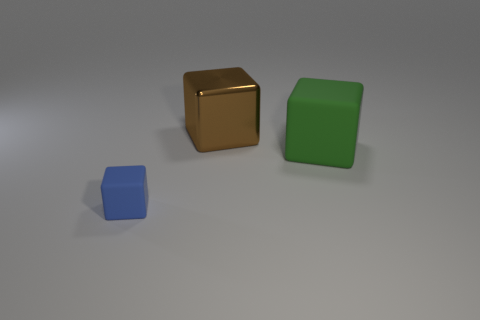How many other objects are there of the same material as the blue object?
Your answer should be compact. 1. Does the green cube have the same material as the block to the left of the brown shiny block?
Keep it short and to the point. Yes. What number of things are either blue objects that are on the left side of the brown block or objects that are in front of the large green object?
Ensure brevity in your answer.  1. What number of other things are there of the same color as the small matte object?
Your response must be concise. 0. Are there more brown metallic cubes behind the big brown metallic block than small blocks that are right of the large green thing?
Your response must be concise. No. Is there any other thing that has the same size as the brown metal cube?
Provide a succinct answer. Yes. What number of cubes are either big shiny objects or big green things?
Your answer should be compact. 2. How many objects are matte cubes that are to the left of the large metal object or green objects?
Provide a succinct answer. 2. What shape is the rubber thing that is on the right side of the rubber thing in front of the thing that is right of the large brown block?
Your response must be concise. Cube. How many other small objects are the same shape as the tiny blue rubber object?
Your answer should be very brief. 0. 